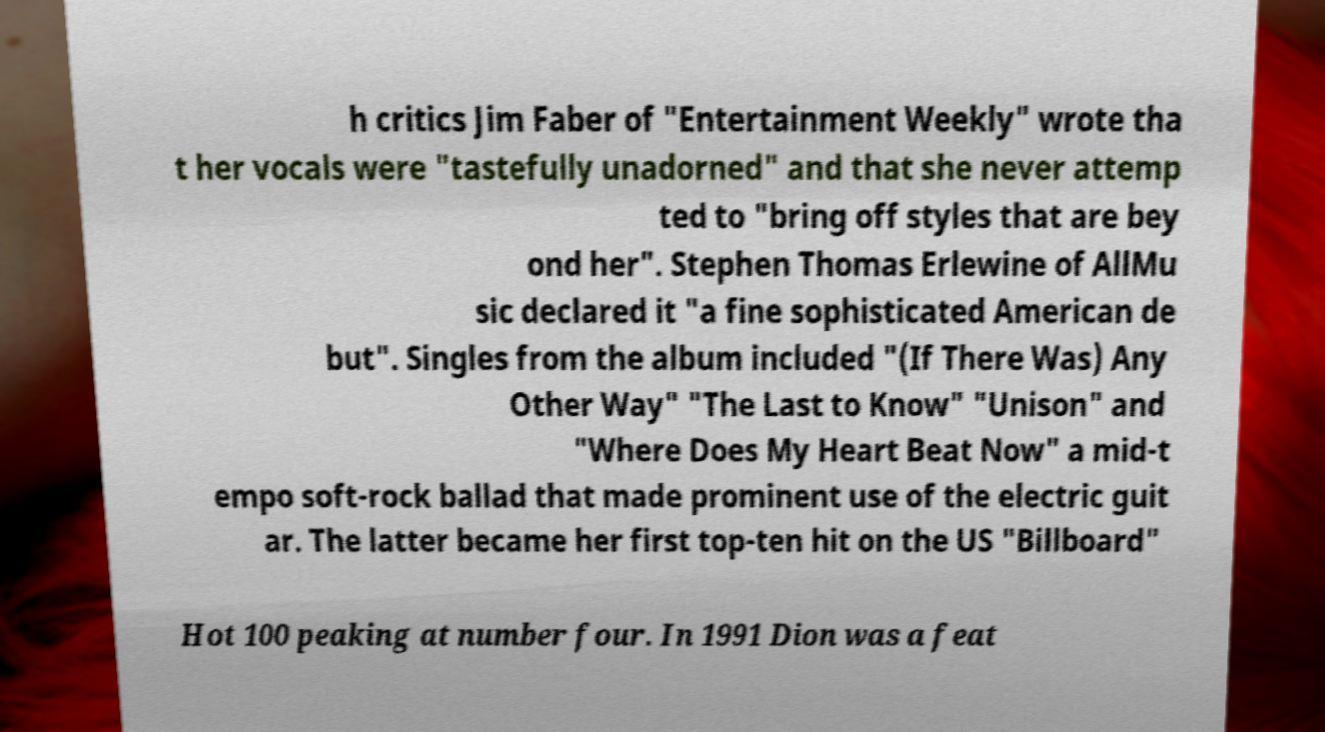I need the written content from this picture converted into text. Can you do that? h critics Jim Faber of "Entertainment Weekly" wrote tha t her vocals were "tastefully unadorned" and that she never attemp ted to "bring off styles that are bey ond her". Stephen Thomas Erlewine of AllMu sic declared it "a fine sophisticated American de but". Singles from the album included "(If There Was) Any Other Way" "The Last to Know" "Unison" and "Where Does My Heart Beat Now" a mid-t empo soft-rock ballad that made prominent use of the electric guit ar. The latter became her first top-ten hit on the US "Billboard" Hot 100 peaking at number four. In 1991 Dion was a feat 